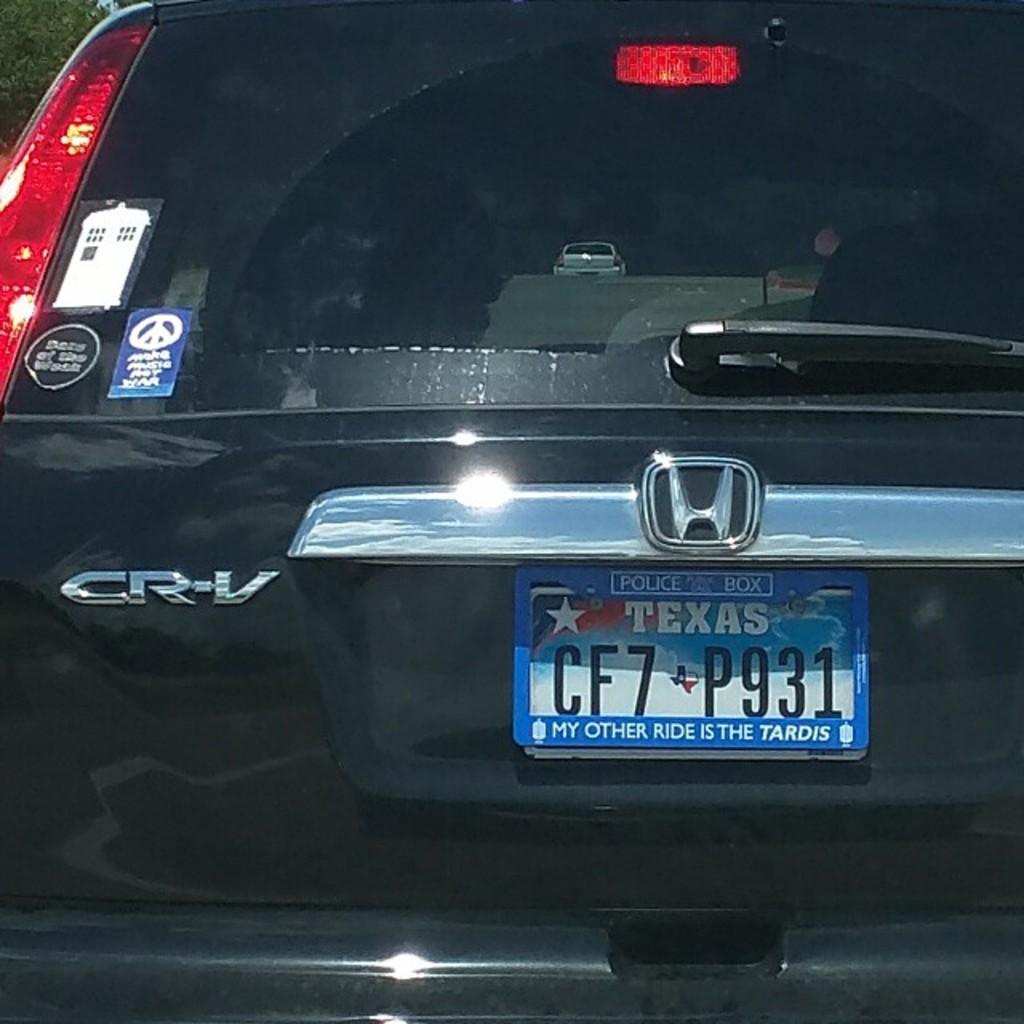<image>
Relay a brief, clear account of the picture shown. A Honda CR-V with Texas plates has a Doctor Who plate frame. 